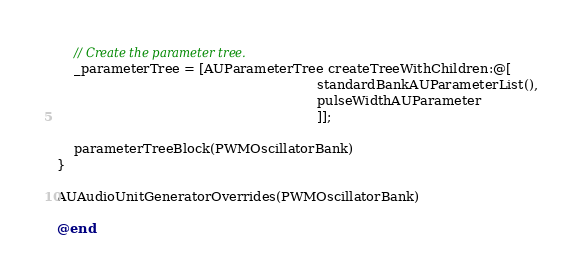<code> <loc_0><loc_0><loc_500><loc_500><_ObjectiveC_>
    // Create the parameter tree.
    _parameterTree = [AUParameterTree createTreeWithChildren:@[
                                                               standardBankAUParameterList(),
                                                               pulseWidthAUParameter
                                                               ]];

    parameterTreeBlock(PWMOscillatorBank)
}

AUAudioUnitGeneratorOverrides(PWMOscillatorBank)

@end


</code> 